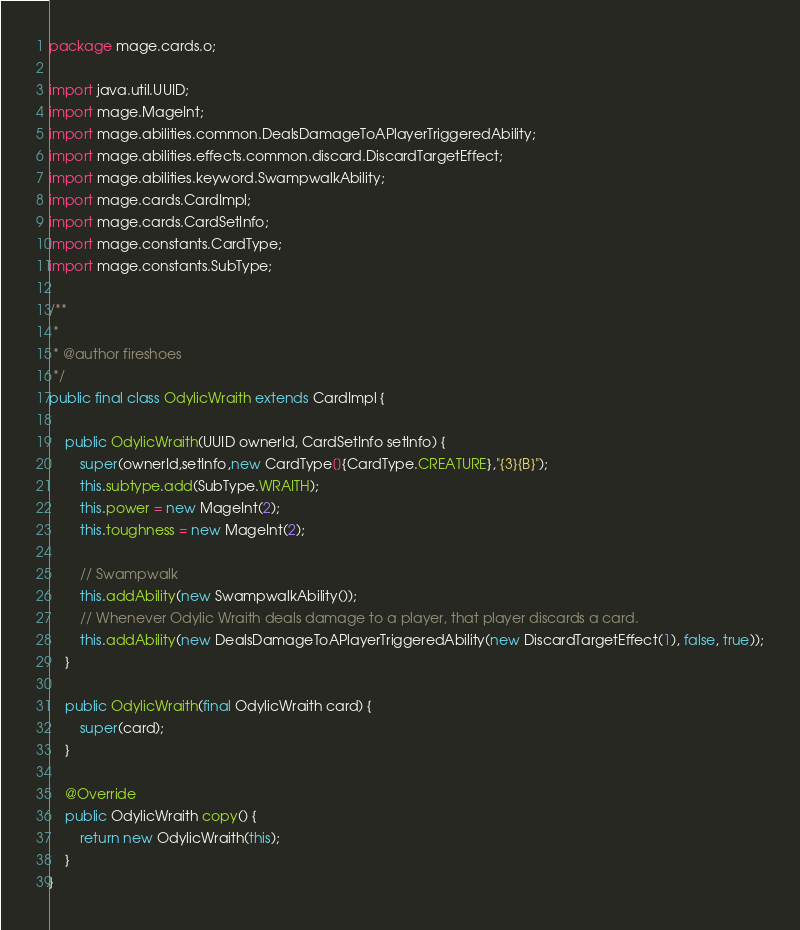<code> <loc_0><loc_0><loc_500><loc_500><_Java_>
package mage.cards.o;

import java.util.UUID;
import mage.MageInt;
import mage.abilities.common.DealsDamageToAPlayerTriggeredAbility;
import mage.abilities.effects.common.discard.DiscardTargetEffect;
import mage.abilities.keyword.SwampwalkAbility;
import mage.cards.CardImpl;
import mage.cards.CardSetInfo;
import mage.constants.CardType;
import mage.constants.SubType;

/**
 *
 * @author fireshoes
 */
public final class OdylicWraith extends CardImpl {

    public OdylicWraith(UUID ownerId, CardSetInfo setInfo) {
        super(ownerId,setInfo,new CardType[]{CardType.CREATURE},"{3}{B}");
        this.subtype.add(SubType.WRAITH);
        this.power = new MageInt(2);
        this.toughness = new MageInt(2);

        // Swampwalk
        this.addAbility(new SwampwalkAbility());
        // Whenever Odylic Wraith deals damage to a player, that player discards a card.
        this.addAbility(new DealsDamageToAPlayerTriggeredAbility(new DiscardTargetEffect(1), false, true));
    }

    public OdylicWraith(final OdylicWraith card) {
        super(card);
    }

    @Override
    public OdylicWraith copy() {
        return new OdylicWraith(this);
    }
}
</code> 